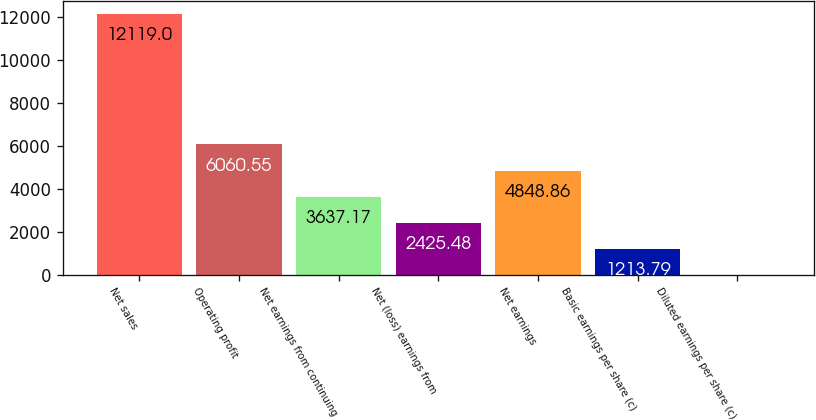<chart> <loc_0><loc_0><loc_500><loc_500><bar_chart><fcel>Net sales<fcel>Operating profit<fcel>Net earnings from continuing<fcel>Net (loss) earnings from<fcel>Net earnings<fcel>Basic earnings per share (c)<fcel>Diluted earnings per share (c)<nl><fcel>12119<fcel>6060.55<fcel>3637.17<fcel>2425.48<fcel>4848.86<fcel>1213.79<fcel>2.1<nl></chart> 